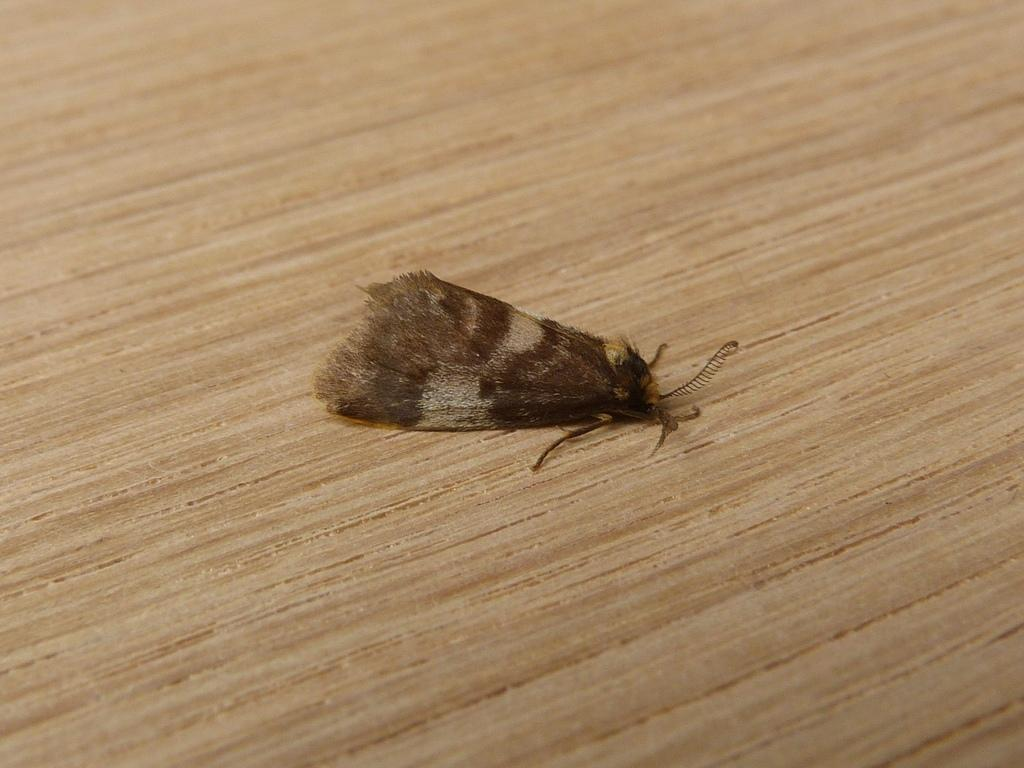What is the main subject of the image? There is a moth in the middle of the image. What type of surface is visible at the bottom of the image? There is a wooden surface at the bottom of the image. What type of bread is being used as a credit card in the image? There is no bread or credit card present in the image; it only features a moth and a wooden surface. 